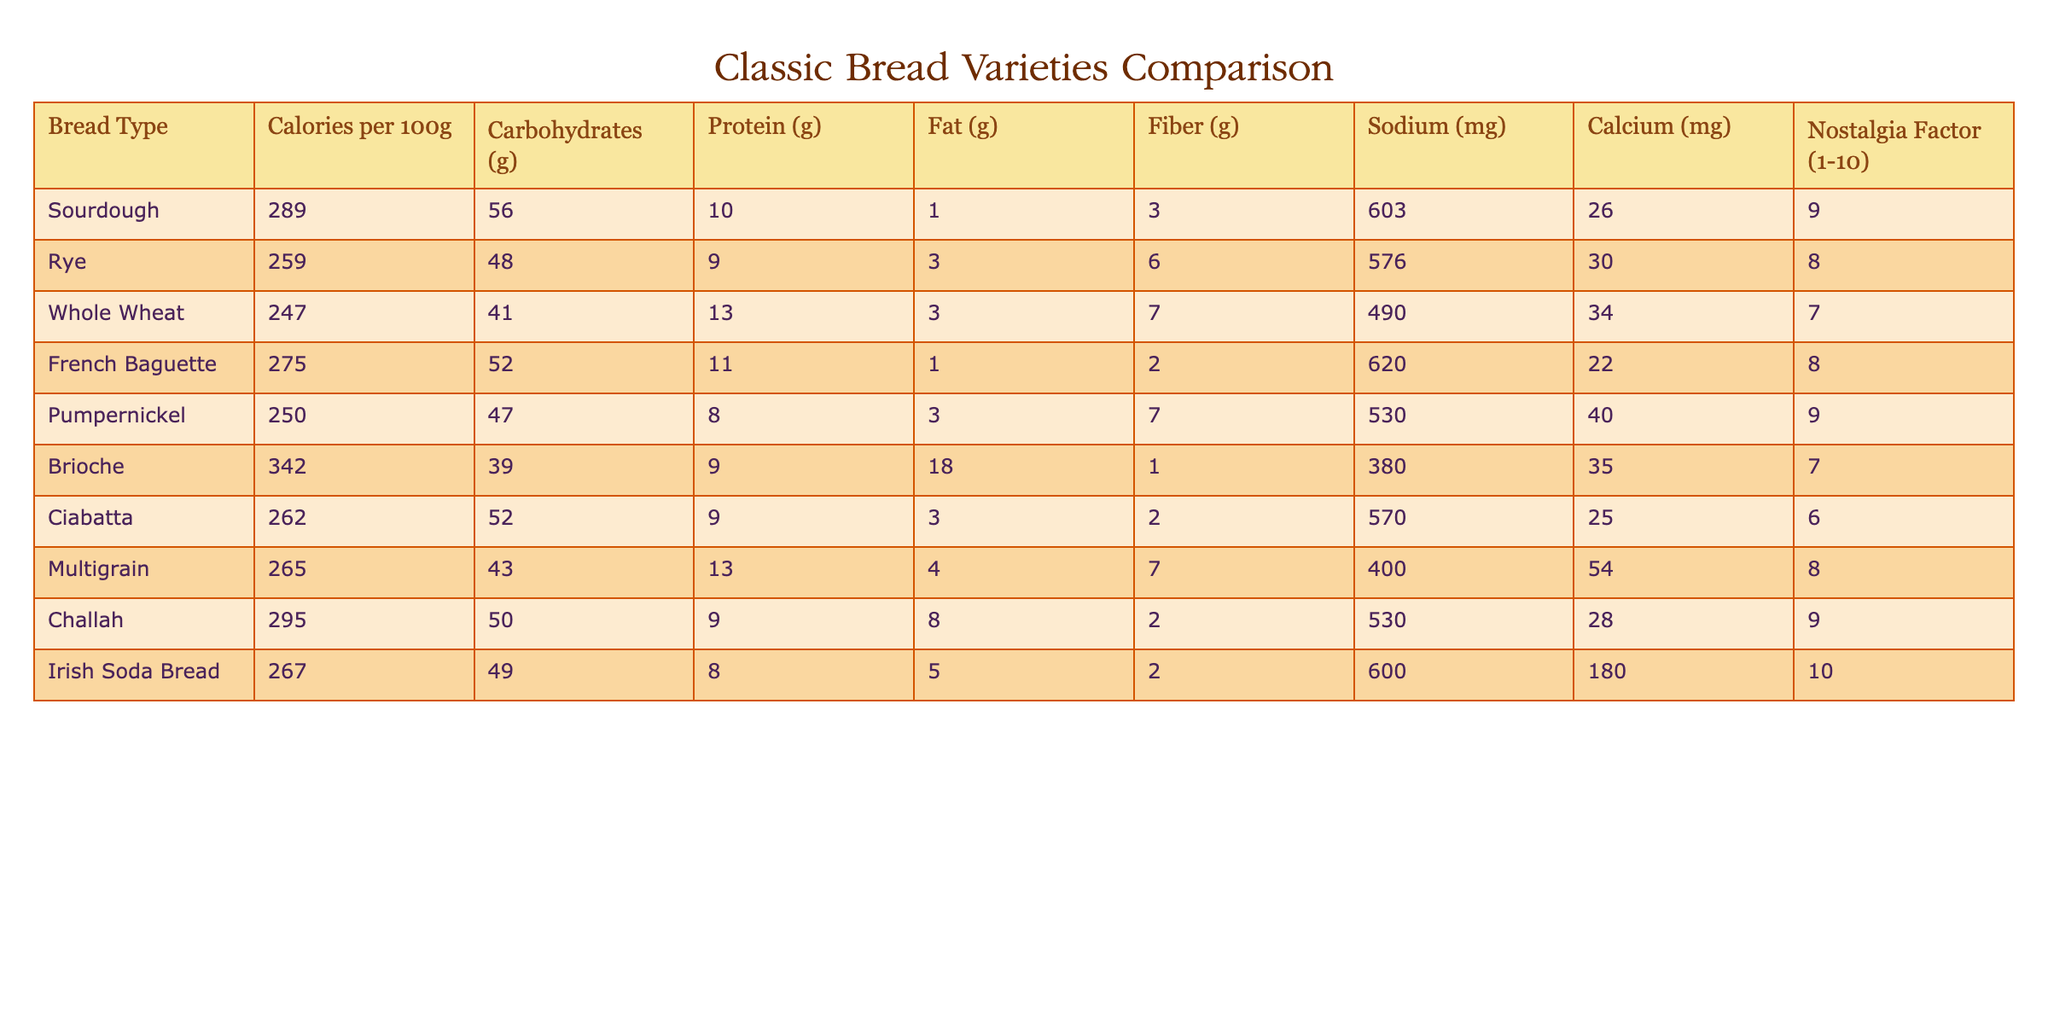What is the highest calorie bread variety in the table? The highest calorie bread in the table is Brioche, with 342 calories per 100g. This can be found by comparing the "Calories per 100g" column for each bread variety listed.
Answer: 342 Which bread variety has the lowest sodium content? The bread variety with the lowest sodium content is Multigrain, which has 400 mg of sodium. This is determined by looking at the "Sodium (mg)" column and identifying the smallest value.
Answer: 400 What is the average protein content of the breads listed? To find the average protein content, I first sum the protein values: (10 + 9 + 13 + 11 + 8 + 9 + 9 + 13 + 9 + 8) = 88. There are 10 types of bread, so the average is 88 / 10 = 8.8 grams.
Answer: 8.8 Does Sourdough have more carbohydrates than Whole Wheat? Yes, Sourdough has 56 grams of carbohydrates, while Whole Wheat has 41 grams. Comparing these two values confirms that Sourdough has more carbohydrates.
Answer: Yes Which bread variety offers the highest nostalgia factor and what is it? The bread variety with the highest nostalgia factor is Irish Soda Bread with a nostalgia factor of 10. This is identified by checking the "Nostalgia Factor (1-10)" column for the highest value.
Answer: Irish Soda Bread What is the difference in fiber content between Pumpernickel and Brioche? Pumpernickel has 7 grams of fiber, while Brioche has only 1 gram. The difference is calculated as 7 - 1 = 6 grams. This means Pumpernickel has more fiber.
Answer: 6 Which breads contain more fat than Whole Wheat? French Baguette (1g), Brioche (18g), and Challah (8g) all have more fat than Whole Wheat, which contains 3 grams of fat. I checked the "Fat (g)" column and compared them against the value for Whole Wheat.
Answer: Three breads What is the total carbohydrate content of Sourdough and Ciabatta combined? Sourdough has 56 grams of carbohydrates and Ciabatta has 52 grams. Adding these values together gives 56 + 52 = 108 grams total carbohydrates for both breads combined.
Answer: 108 Does the calorie content of Rye bread exceed that of Pumpernickel? No, Rye contains 259 calories, while Pumpernickel contains 250 calories. Comparing these values shows that Rye does not exceed the calorie content of Pumpernickel.
Answer: No 